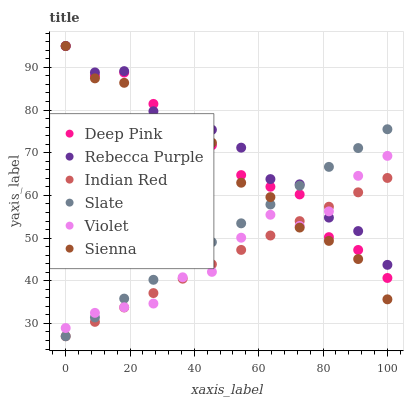Does Indian Red have the minimum area under the curve?
Answer yes or no. Yes. Does Rebecca Purple have the maximum area under the curve?
Answer yes or no. Yes. Does Slate have the minimum area under the curve?
Answer yes or no. No. Does Slate have the maximum area under the curve?
Answer yes or no. No. Is Indian Red the smoothest?
Answer yes or no. Yes. Is Sienna the roughest?
Answer yes or no. Yes. Is Slate the smoothest?
Answer yes or no. No. Is Slate the roughest?
Answer yes or no. No. Does Slate have the lowest value?
Answer yes or no. Yes. Does Sienna have the lowest value?
Answer yes or no. No. Does Rebecca Purple have the highest value?
Answer yes or no. Yes. Does Slate have the highest value?
Answer yes or no. No. Does Rebecca Purple intersect Slate?
Answer yes or no. Yes. Is Rebecca Purple less than Slate?
Answer yes or no. No. Is Rebecca Purple greater than Slate?
Answer yes or no. No. 